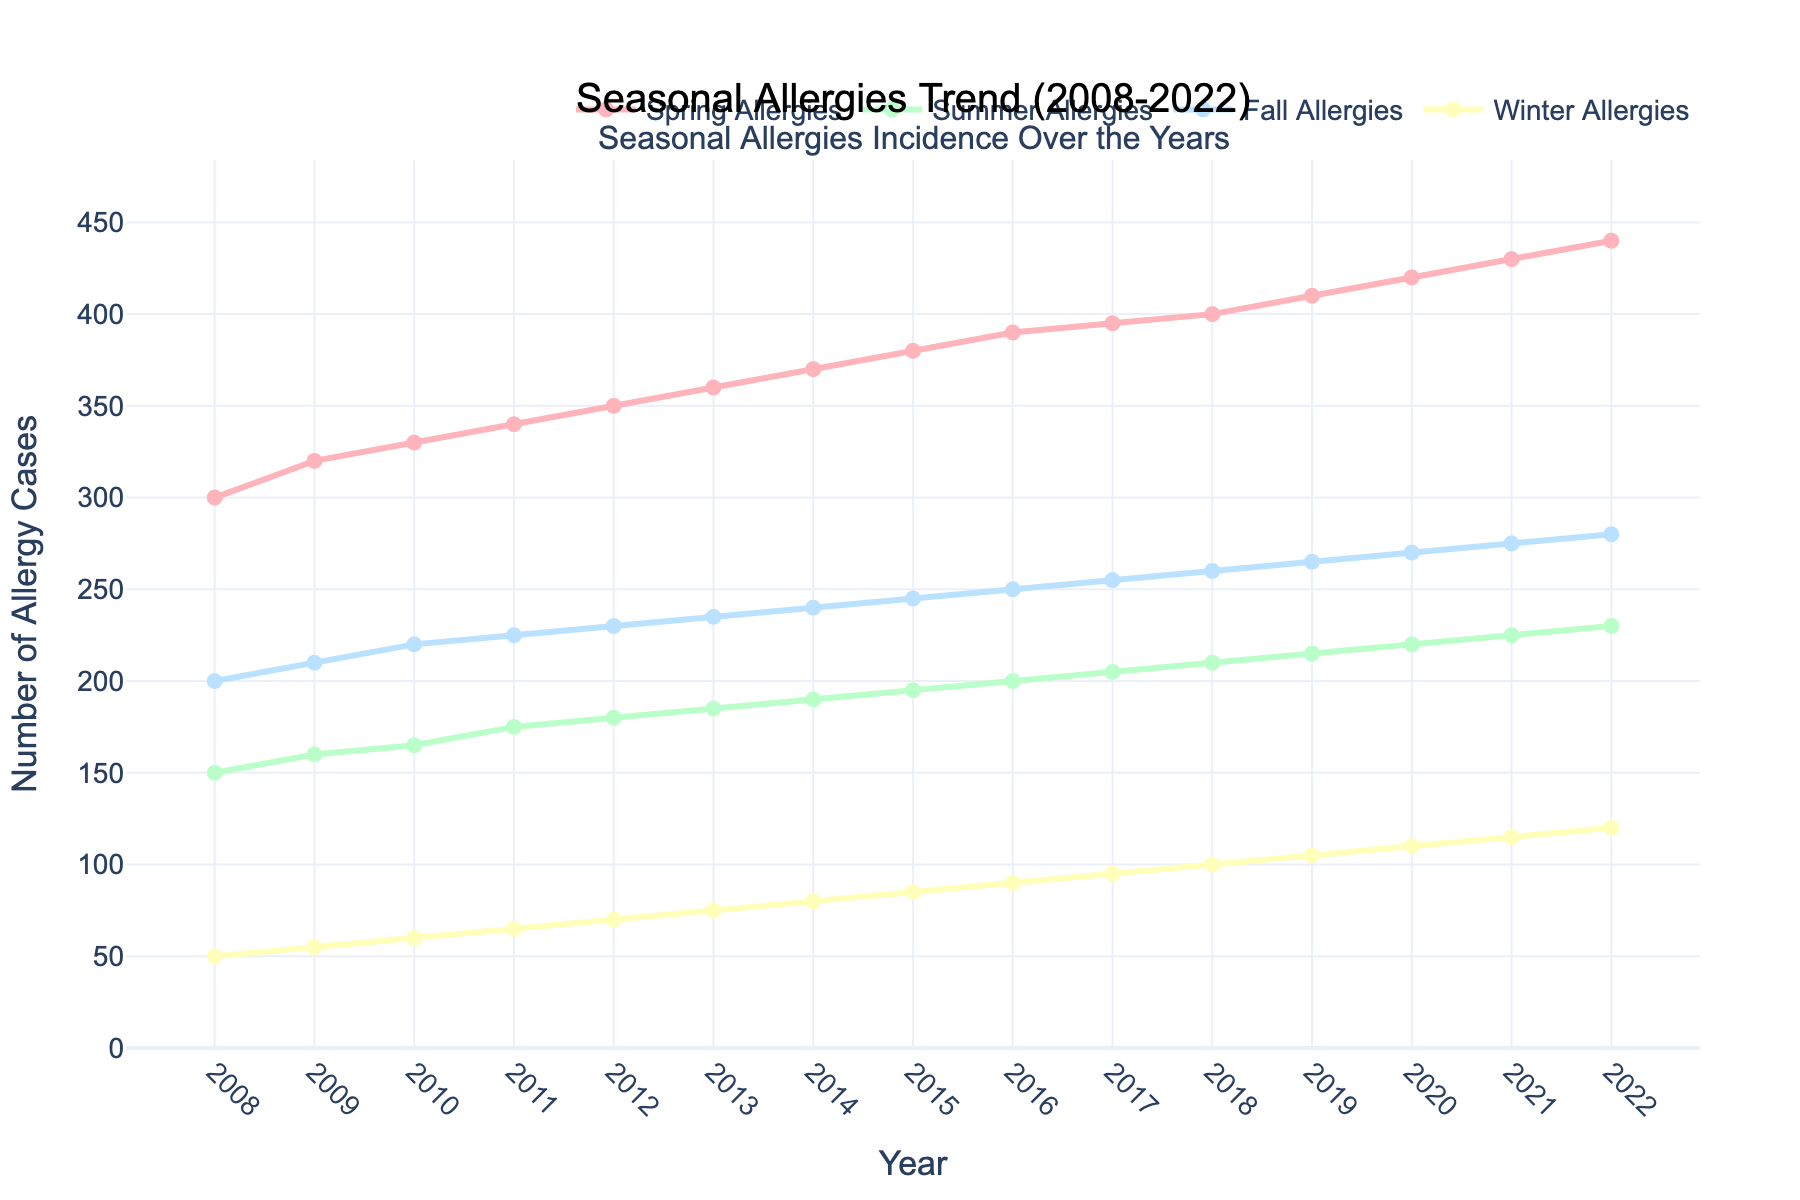What's the title of the figure? The title is located at the top of the figure and typically summarizes the content of the plot. In this case, it should be about seasonal allergy trends over a specific period.
Answer: Seasonal Allergies Trend (2008-2022) How many seasons are plotted in the figure? By examining the legend or the different colored lines in the plot, one can determine the number of seasons being depicted.
Answer: Four Which season had the highest number of allergy cases in 2022? Look at the ending points of each line in 2022. Identify which line reaches the highest value on the y-axis.
Answer: Spring Allergies By how much did Spring Allergies cases increase from 2008 to 2022? Find the y-values for Spring Allergies in the years 2008 and 2022, then calculate the difference between these two values.
Answer: 140 cases What's the trend of Winter Allergies over the 15 years? Observe the line representing Winter Allergies from the start year to the end year. Determine if it's increasing, decreasing, or remaining stable.
Answer: Increasing Which year had the largest increase in Fall Allergies compared to the previous year? Calculate the differences in Fall Allergies between consecutive years and find out which year shows the largest increase.
Answer: 2015 (an increase of 5 cases) What's the average number of Summer Allergies cases from 2008 to 2022? Add up all the Summer Allergies cases from 2008 to 2022 and then divide by the number of years (15).
Answer: 190 cases Are there any years where Fall Allergies and Winter Allergies had the same number of cases? Compare the y-values for each year to check if at any point the values for Fall Allergies and Winter Allergies are equal.
Answer: No Which season shows the most consistent increase in allergy cases over the years? By visually examining the slopes of the lines, identify which one has the most consistent upward trend.
Answer: Spring Allergies If current trends continue, which season is likely to have the highest number of allergies in 2025? Extrapolate the current trends of each season's line beyond the last point to predict future values.
Answer: Spring Allergies 